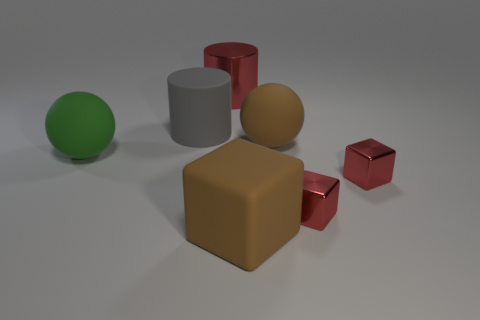How many big rubber things are the same color as the matte cube?
Provide a succinct answer. 1. The ball to the right of the big gray cylinder is what color?
Your answer should be compact. Brown. How many red objects are big cubes or cubes?
Keep it short and to the point. 2. What color is the big matte cube?
Keep it short and to the point. Brown. Are there fewer big gray matte cylinders that are in front of the gray rubber cylinder than red objects that are in front of the large red shiny cylinder?
Give a very brief answer. Yes. What shape is the matte object that is both to the left of the red cylinder and in front of the gray matte object?
Offer a very short reply. Sphere. What number of red shiny objects have the same shape as the gray thing?
Your answer should be very brief. 1. There is a gray object that is made of the same material as the brown ball; what is its size?
Offer a very short reply. Large. What number of green metallic cubes are the same size as the green rubber object?
Your response must be concise. 0. There is a thing that is the same color as the big cube; what size is it?
Your answer should be very brief. Large. 